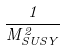<formula> <loc_0><loc_0><loc_500><loc_500>\frac { 1 } { M _ { S U S Y } ^ { 2 } }</formula> 